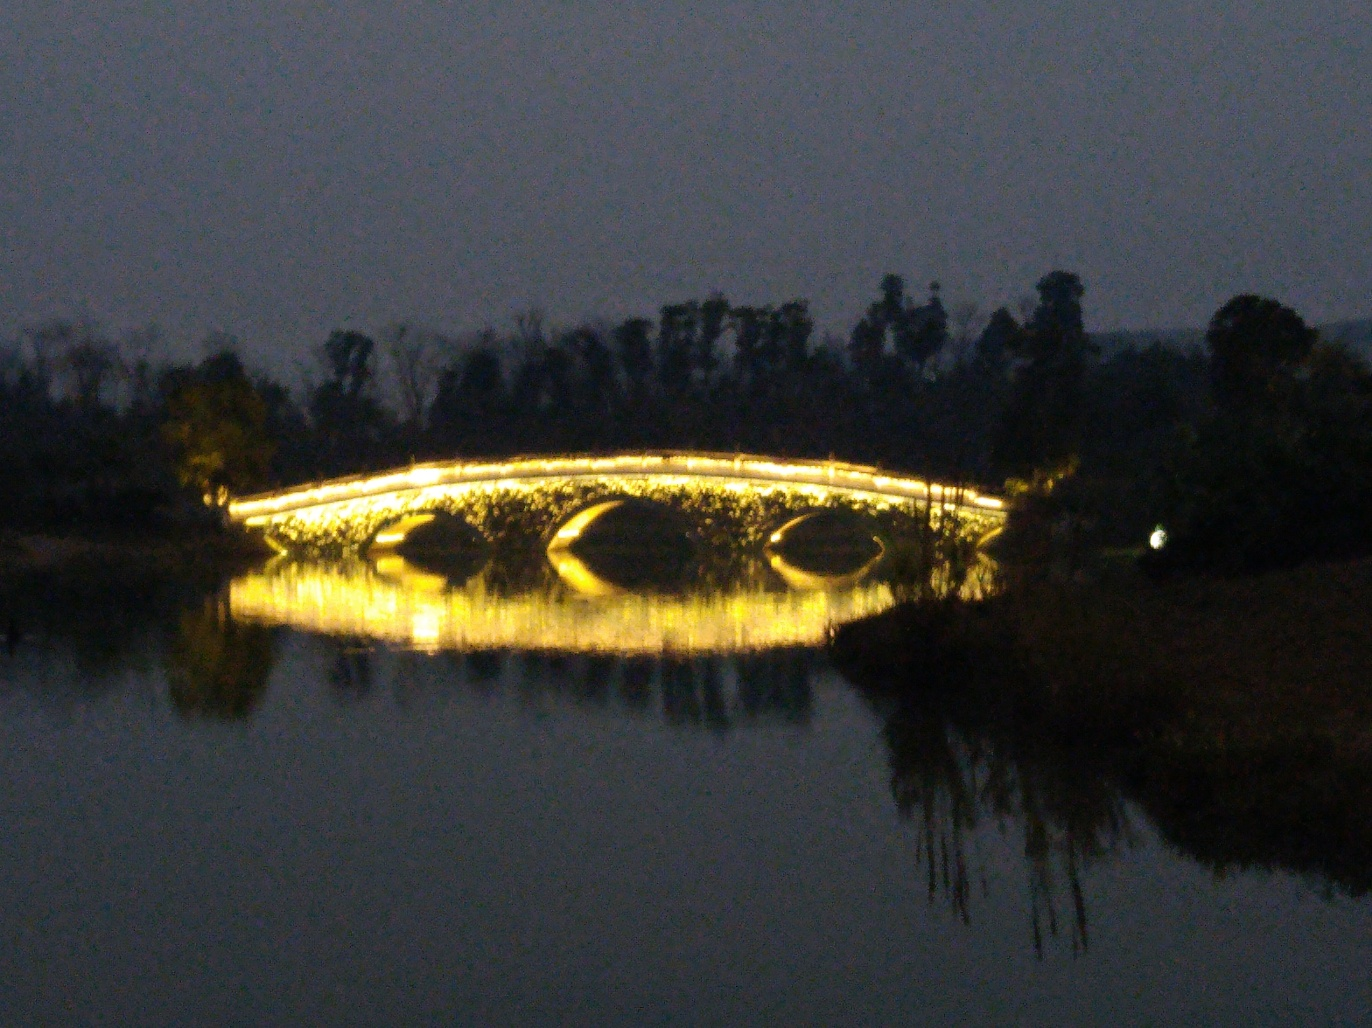What can be said about the content of this image?
A. interesting
B. colorful
C. captivating
D. monotonous The image depicts a bridge illuminated at night, creating a serene and somewhat captivating atmosphere. The reflections on the water add a touch of magic to the scene, making option C, captivating, the most accurate description. While the colors are not vibrant due to the nighttime setting, the lighting does impart a sense of interest and beauty. 